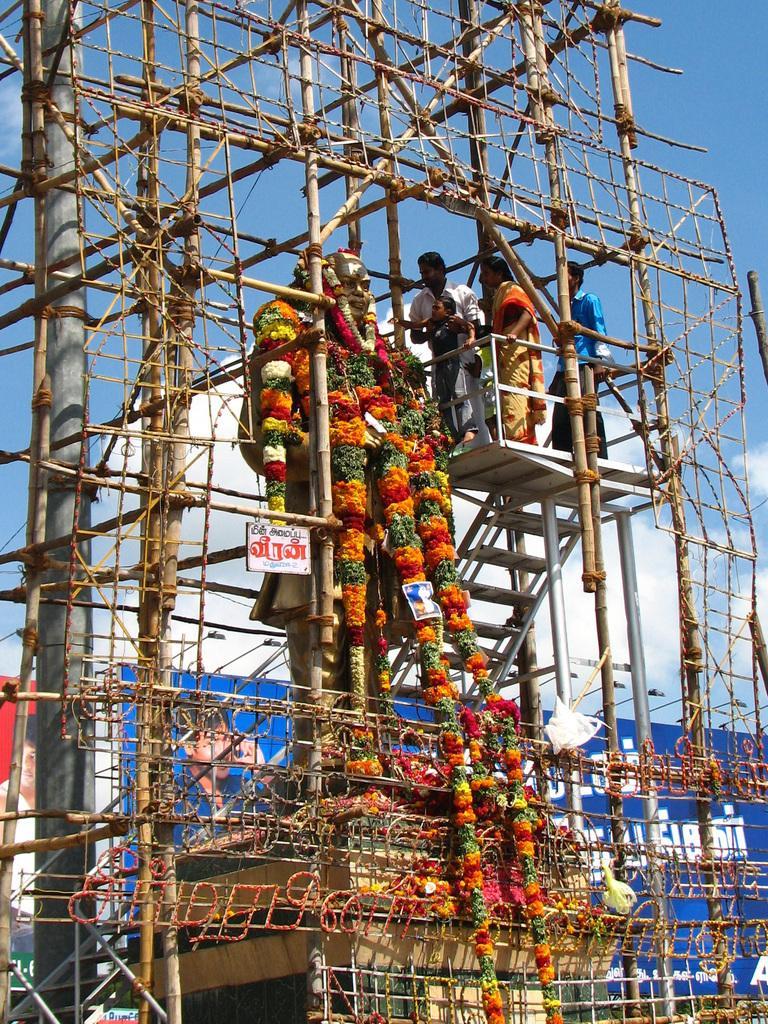How would you summarize this image in a sentence or two? In the picture we can see a statue of a person and many garland on it and beside it, we can see some steps and surface on it with a railing and some people standing on it and looking at the statue and around the statue we can see sticks construction and in the background we can see a hoarding and lights to it and behind it we can see a sky. 